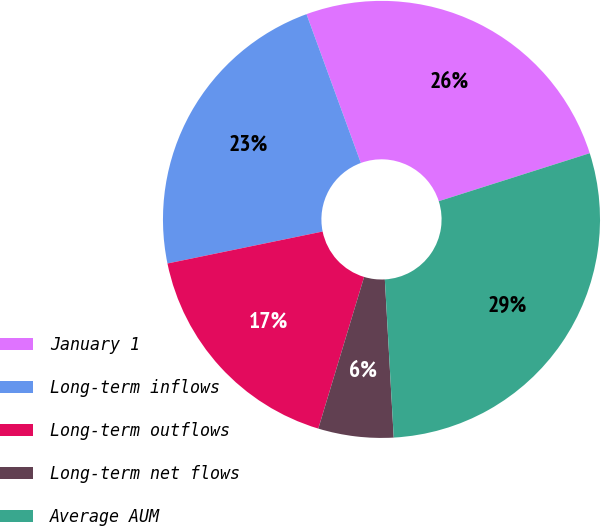<chart> <loc_0><loc_0><loc_500><loc_500><pie_chart><fcel>January 1<fcel>Long-term inflows<fcel>Long-term outflows<fcel>Long-term net flows<fcel>Average AUM<nl><fcel>25.68%<fcel>22.66%<fcel>17.1%<fcel>5.56%<fcel>29.01%<nl></chart> 